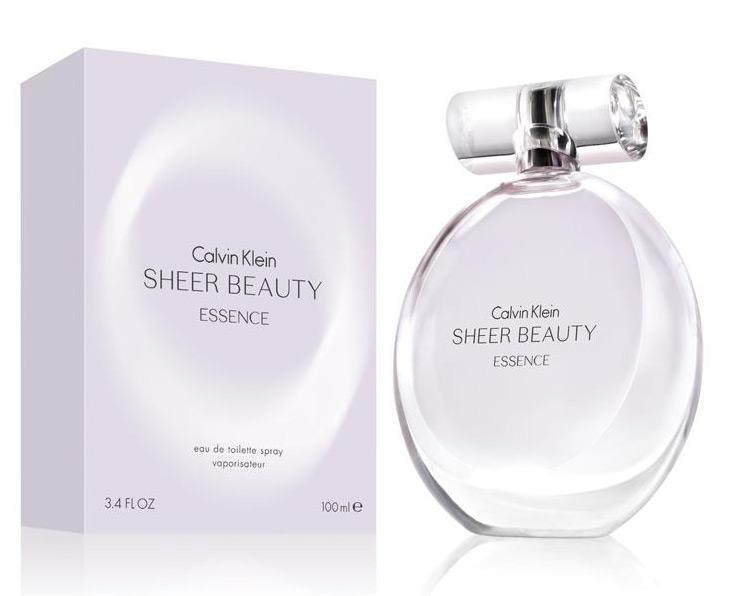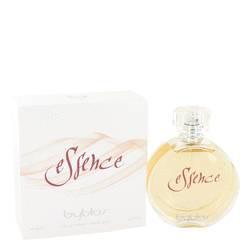The first image is the image on the left, the second image is the image on the right. Given the left and right images, does the statement "There is a round perfume bottle on the left." hold true? Answer yes or no. Yes. 